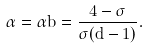Convert formula to latex. <formula><loc_0><loc_0><loc_500><loc_500>\alpha = \alpha b = \frac { 4 - \sigma } { \sigma ( d - 1 ) } .</formula> 